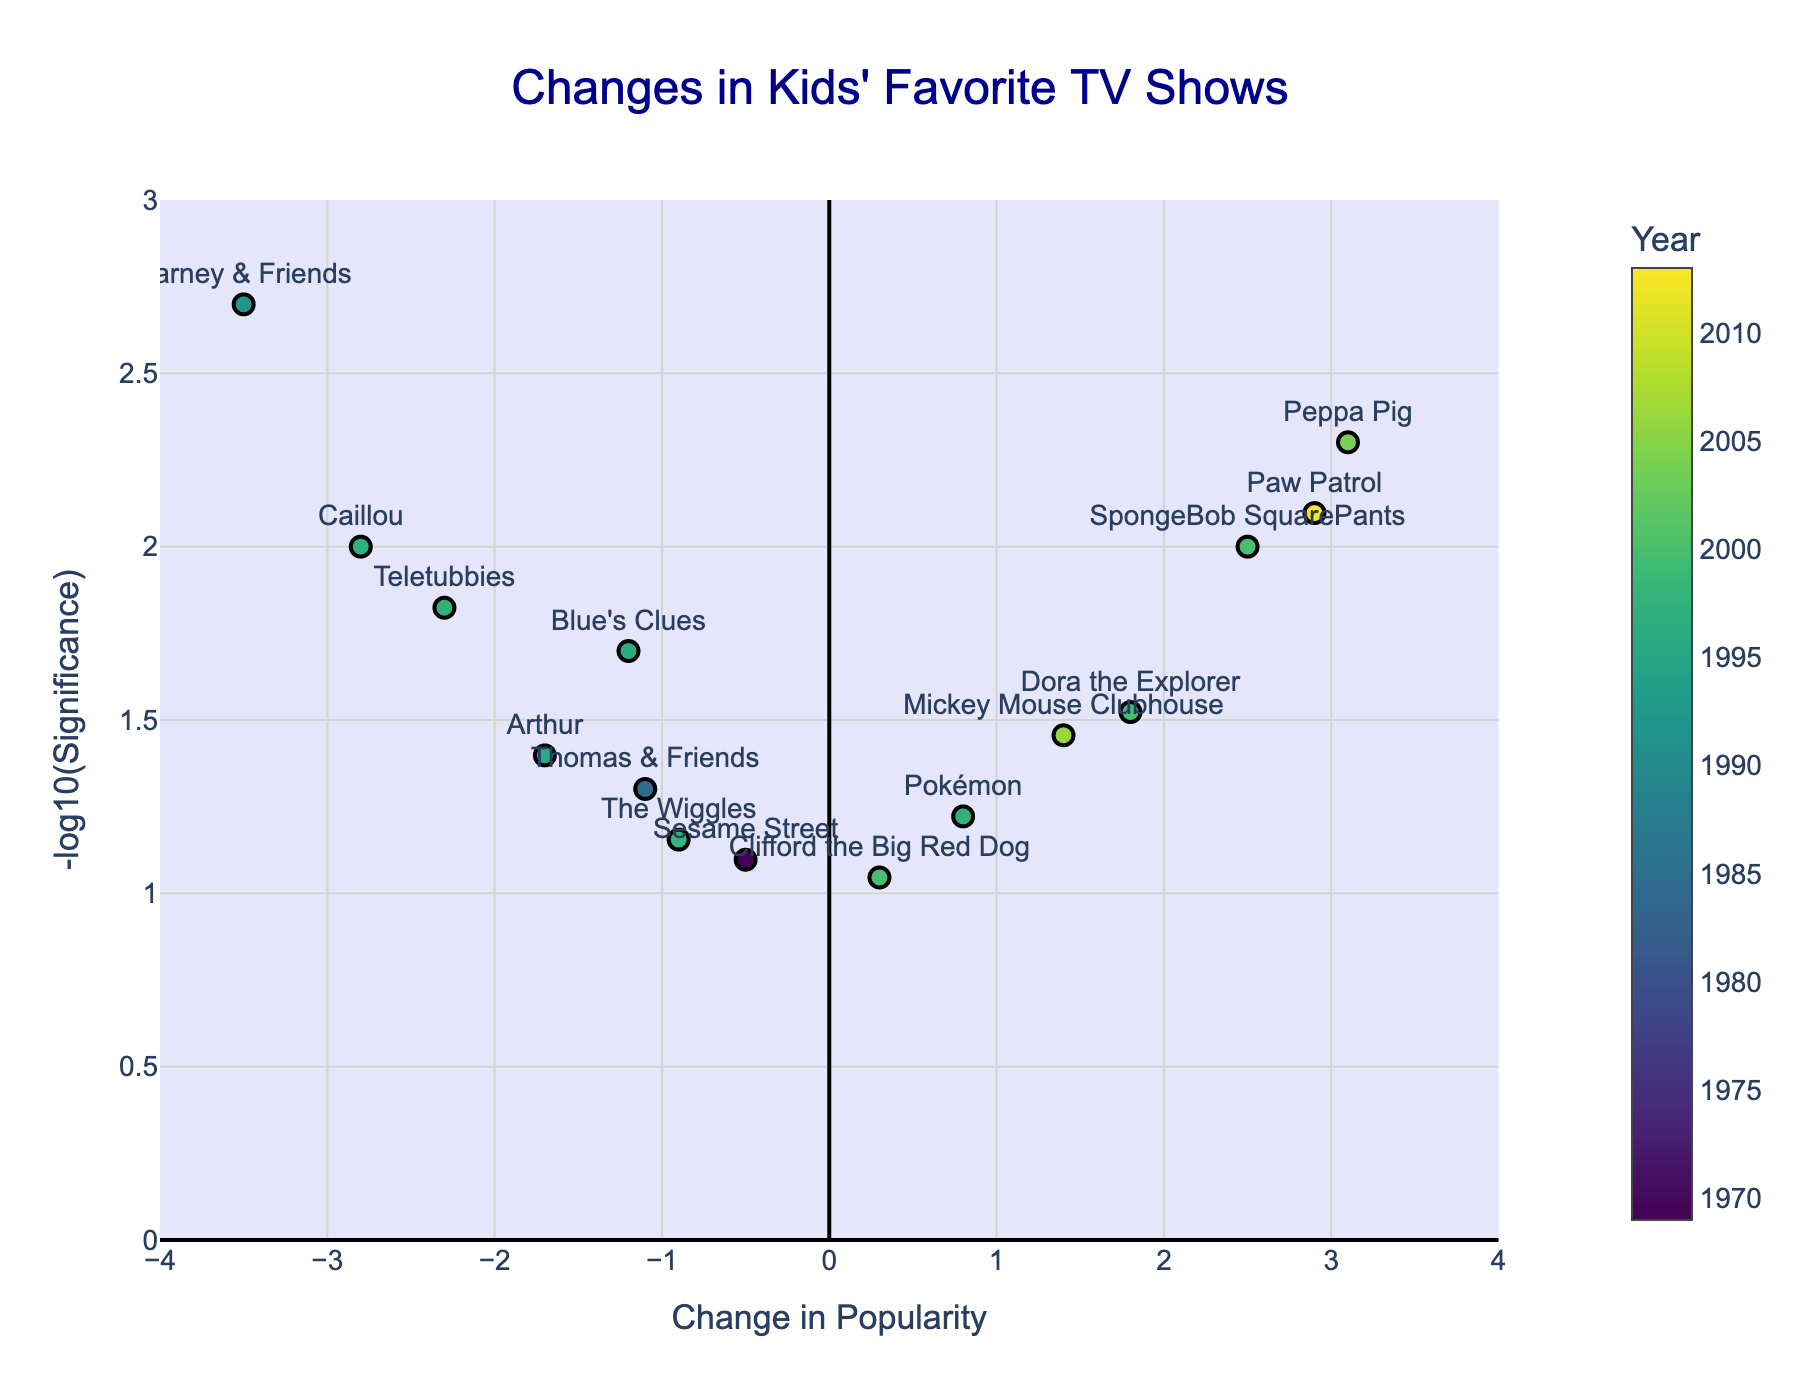What is the title of the plot? The title of the plot is usually found at the top center of the figure. In this case, it mentions "Changes in Kids' Favorite TV Shows".
Answer: Changes in Kids' Favorite TV Shows How is the x-axis labeled? The x-axis label is usually found underneath the horizontal axis on the figure. It describes what's being measured along that axis. Here, it says "Change in Popularity".
Answer: Change in Popularity Which show had the most significant increase in popularity? To find the show with the most significant increase in popularity, look for the highest point on the right-hand side of the plot. The show associated with the highest dot is "Peppa Pig".
Answer: Peppa Pig Which show had the biggest drop in popularity? Look for the point with the lowest value on the x-axis. That point corresponds to "Barney & Friends".
Answer: Barney & Friends Which show is represented by a point with a value of around -0.9 for popularity change? Find the point on the x-axis around -0.9 and check the label associated with this point. "The Wiggles" corresponds to this location.
Answer: The Wiggles Which show from 1996 saw a decrease in popularity? Look at the points marked as 1996; there are two. Identify which one has a negative x-axis value. The show is "Arthur".
Answer: Arthur What year had the most shows experiencing changes in popularity? Count the number of shows for each year and identify the year with the most entries. The year "1997" had multiple shows listed, specifically three: Blue's Clues, Teletubbies, and Caillou.
Answer: 1997 How many shows had a significance level lower than 0.01? Examine the y-axis values, which represent -log10(significance). A significance level lower than 0.01 corresponds to any y-axis value above 2. This condition is met by "Barney & Friends" and "Peppa Pig".
Answer: 2 Which pairs of shows had very similar changes in popularity but different years? Look for points that are close to each other along the x-axis but different in color, indicating different years. One example is "Pokémon" and "Clifford the Big Red Dog", both having around 0.3 but released in different years.
Answer: Pokémon and Clifford the Big Red Dog 